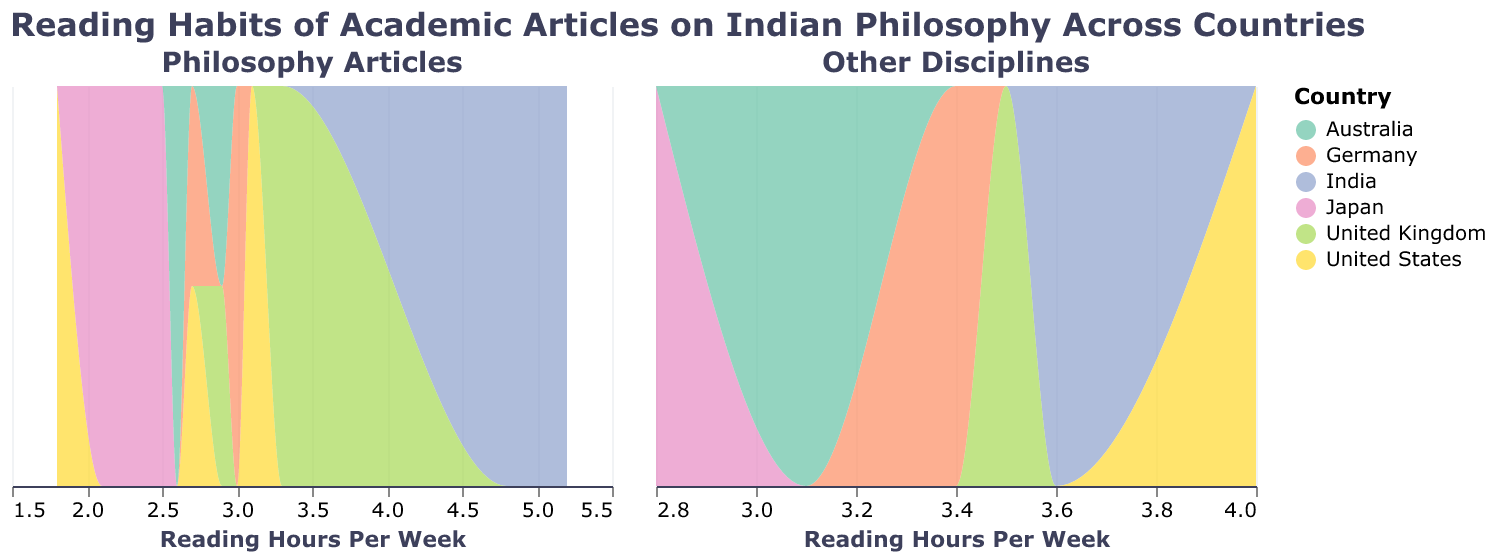Which country has the highest reading hours per week for Philosophy articles? In the subplot for Philosophy articles, observe the peak position along the X-axis for each country. The highest peak is for India at around 5.2 hours per week.
Answer: India Which country reads Philosophy articles the least on average? Compare the density peaks of all countries in the Philosophy subplot. The United States has a lower peak around 1.8 hours per week, indicating it reads the least on average.
Answer: United States How does the reading time of India compare to that of Japan in the philosophy subplot? Compare the positions of the peaks for India and Japan in the Philosophy subplot. India's peak is around 5.2 hours per week, while Japan's peak is around 2.5-2.8 hours per week.
Answer: India reads more than Japan Which category, Philosophy or Other Disciplines, shows a wider range of reading hours per week? Observe the spread of reading hours on the X-axis for both subplots. The Philosophy subplot shows a wider range (1.8 to 5.2 hours) compared to Other Disciplines (2.6 to 4.0 hours).
Answer: Philosophy What is the most common reading hours range for articles in Technology Integration across all countries? Check the density peak in the Other Disciplines subplot for Technology Integration articles. Most peaks appear around 3.1 hours per week.
Answer: 3.1 hours per week Which country has the most variability in reading hours for Philosophy articles? Assess the spread and height of density curves in the Philosophy subplot. India shows the most variability with peaks at 3.6, 4.8, and 5.2 hours per week.
Answer: India Do any countries show similar reading patterns for both Philosophy and Other Disciplines? Compare the density curves for the same country in both subplots. For example, the UK shows similar peaks around 2.9-3.5 hours in both subplots.
Answer: United Kingdom What is the reading hour with the highest density for Review Articles in Cultural Studies? Check the density peak in the Other Disciplines subplot for Cultural Studies. The peak is around 4.0 hours per week.
Answer: 4.0 hours per week How does the average reading time for Scholarly Articles in India compare to that in Australia for Philosophy? Compare the average peak position for Scholarly Articles in India (around 5.0) with Australia (around 2.7-2.9) in the Philosophy subplot.
Answer: India reads more than Australia 